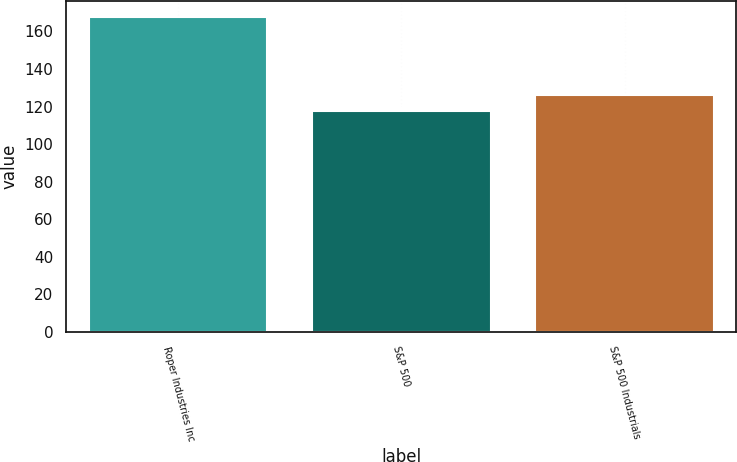Convert chart. <chart><loc_0><loc_0><loc_500><loc_500><bar_chart><fcel>Roper Industries Inc<fcel>S&P 500<fcel>S&P 500 Industrials<nl><fcel>167.89<fcel>117.49<fcel>125.98<nl></chart> 